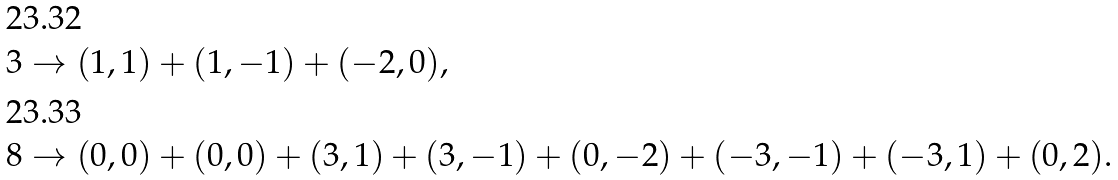<formula> <loc_0><loc_0><loc_500><loc_500>3 & \to ( 1 , 1 ) + ( 1 , - 1 ) + ( - 2 , 0 ) , \\ 8 & \to ( 0 , 0 ) + ( 0 , 0 ) + ( 3 , 1 ) + ( 3 , - 1 ) + ( 0 , - 2 ) + ( - 3 , - 1 ) + ( - 3 , 1 ) + ( 0 , 2 ) .</formula> 